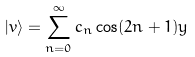Convert formula to latex. <formula><loc_0><loc_0><loc_500><loc_500>| v \rangle = \sum _ { n = 0 } ^ { \infty } c _ { n } \cos ( 2 n + 1 ) y</formula> 